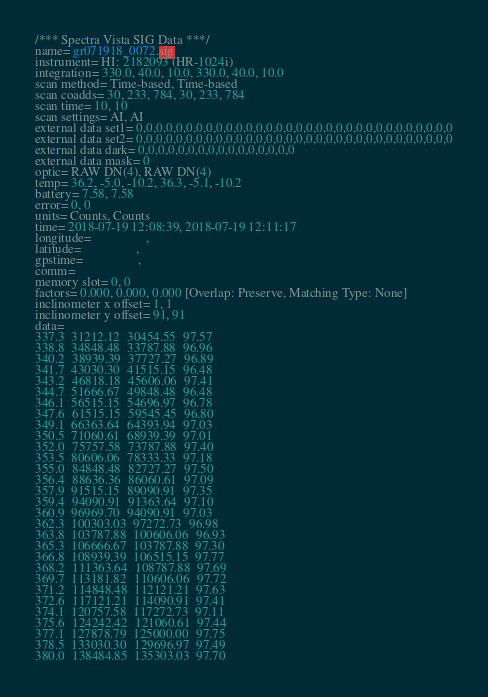Convert code to text. <code><loc_0><loc_0><loc_500><loc_500><_SML_>/*** Spectra Vista SIG Data ***/
name= gr071918_0072.sig
instrument= HI: 2182093 (HR-1024i)
integration= 330.0, 40.0, 10.0, 330.0, 40.0, 10.0
scan method= Time-based, Time-based
scan coadds= 30, 233, 784, 30, 233, 784
scan time= 10, 10
scan settings= AI, AI
external data set1= 0,0,0,0,0,0,0,0,0,0,0,0,0,0,0,0,0,0,0,0,0,0,0,0,0,0,0,0,0,0,0,0
external data set2= 0,0,0,0,0,0,0,0,0,0,0,0,0,0,0,0,0,0,0,0,0,0,0,0,0,0,0,0,0,0,0,0
external data dark= 0,0,0,0,0,0,0,0,0,0,0,0,0,0,0,0
external data mask= 0
optic= RAW DN(4), RAW DN(4)
temp= 36.2, -5.0, -10.2, 36.3, -5.1, -10.2
battery= 7.58, 7.58
error= 0, 0
units= Counts, Counts
time= 2018-07-19 12:08:39, 2018-07-19 12:11:17
longitude=                 ,                 
latitude=                 ,                 
gpstime=                 ,                 
comm= 
memory slot= 0, 0
factors= 0.000, 0.000, 0.000 [Overlap: Preserve, Matching Type: None]
inclinometer x offset= 1, 1
inclinometer y offset= 91, 91
data= 
337.3  31212.12  30454.55  97.57
338.8  34848.48  33787.88  96.96
340.2  38939.39  37727.27  96.89
341.7  43030.30  41515.15  96.48
343.2  46818.18  45606.06  97.41
344.7  51666.67  49848.48  96.48
346.1  56515.15  54696.97  96.78
347.6  61515.15  59545.45  96.80
349.1  66363.64  64393.94  97.03
350.5  71060.61  68939.39  97.01
352.0  75757.58  73787.88  97.40
353.5  80606.06  78333.33  97.18
355.0  84848.48  82727.27  97.50
356.4  88636.36  86060.61  97.09
357.9  91515.15  89090.91  97.35
359.4  94090.91  91363.64  97.10
360.9  96969.70  94090.91  97.03
362.3  100303.03  97272.73  96.98
363.8  103787.88  100606.06  96.93
365.3  106666.67  103787.88  97.30
366.8  108939.39  106515.15  97.77
368.2  111363.64  108787.88  97.69
369.7  113181.82  110606.06  97.72
371.2  114848.48  112121.21  97.63
372.6  117121.21  114090.91  97.41
374.1  120757.58  117272.73  97.11
375.6  124242.42  121060.61  97.44
377.1  127878.79  125000.00  97.75
378.5  133030.30  129696.97  97.49
380.0  138484.85  135303.03  97.70</code> 